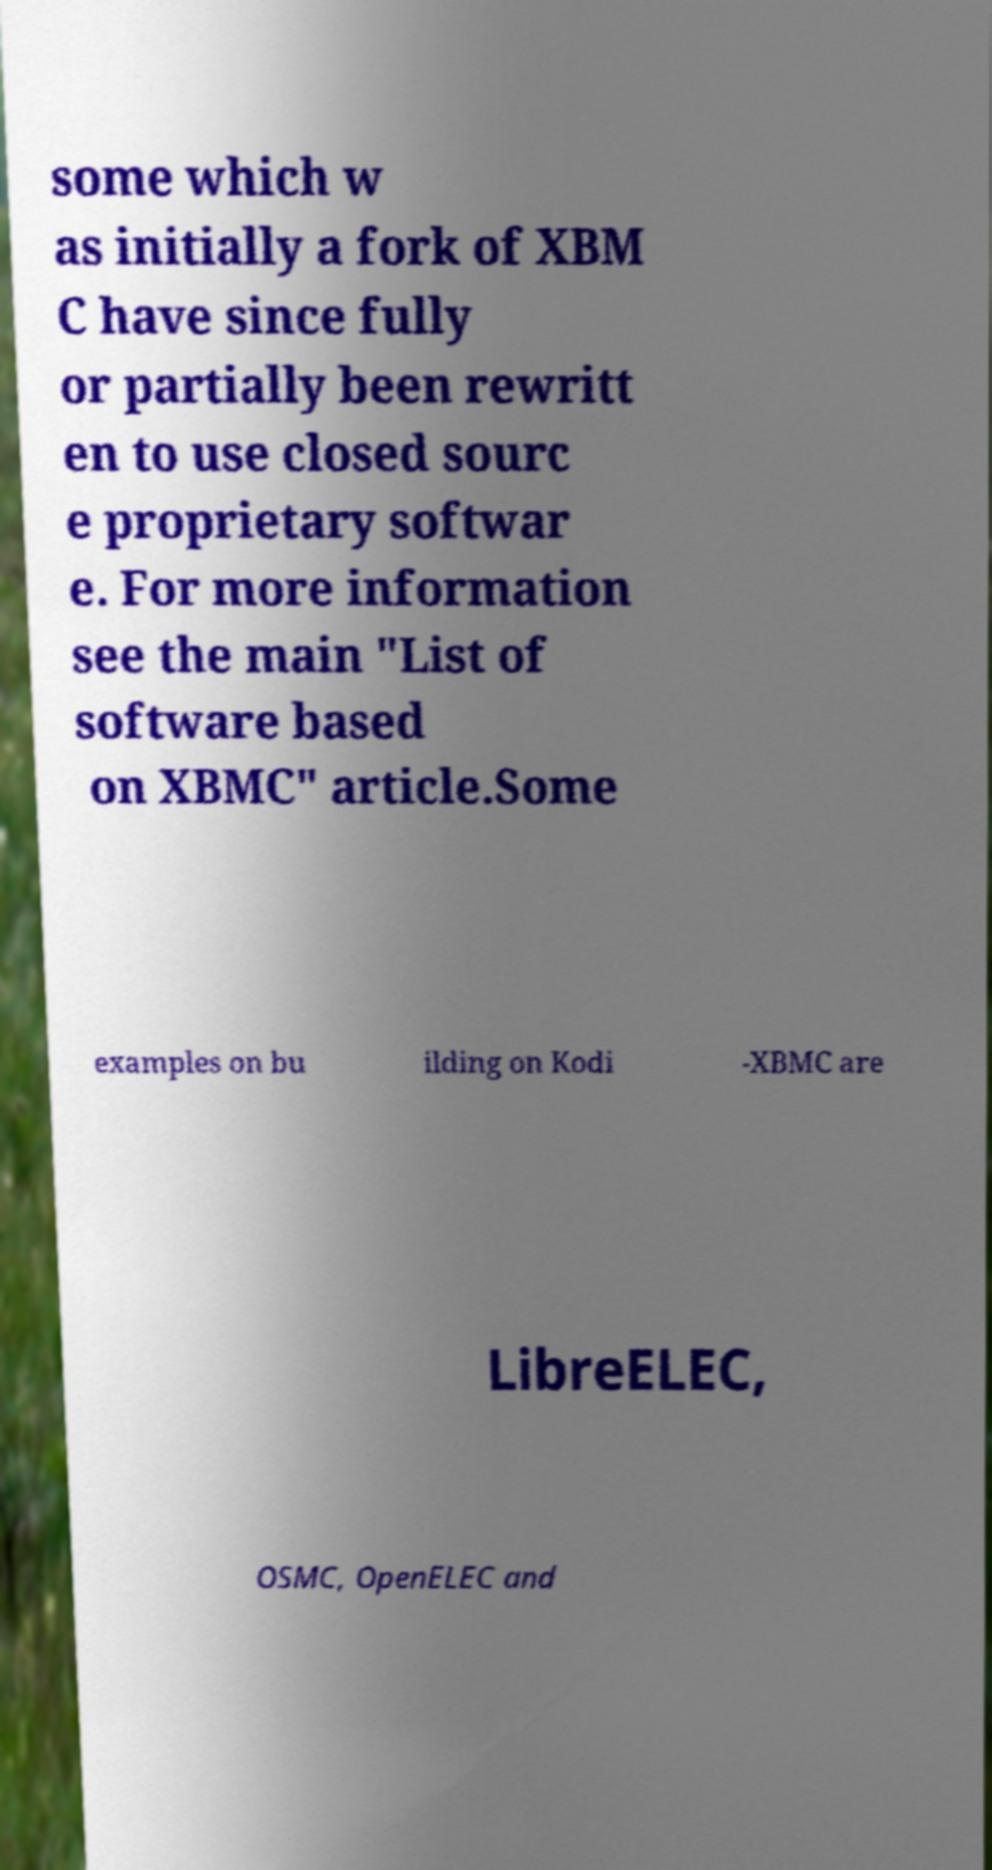Could you assist in decoding the text presented in this image and type it out clearly? some which w as initially a fork of XBM C have since fully or partially been rewritt en to use closed sourc e proprietary softwar e. For more information see the main "List of software based on XBMC" article.Some examples on bu ilding on Kodi -XBMC are LibreELEC, OSMC, OpenELEC and 